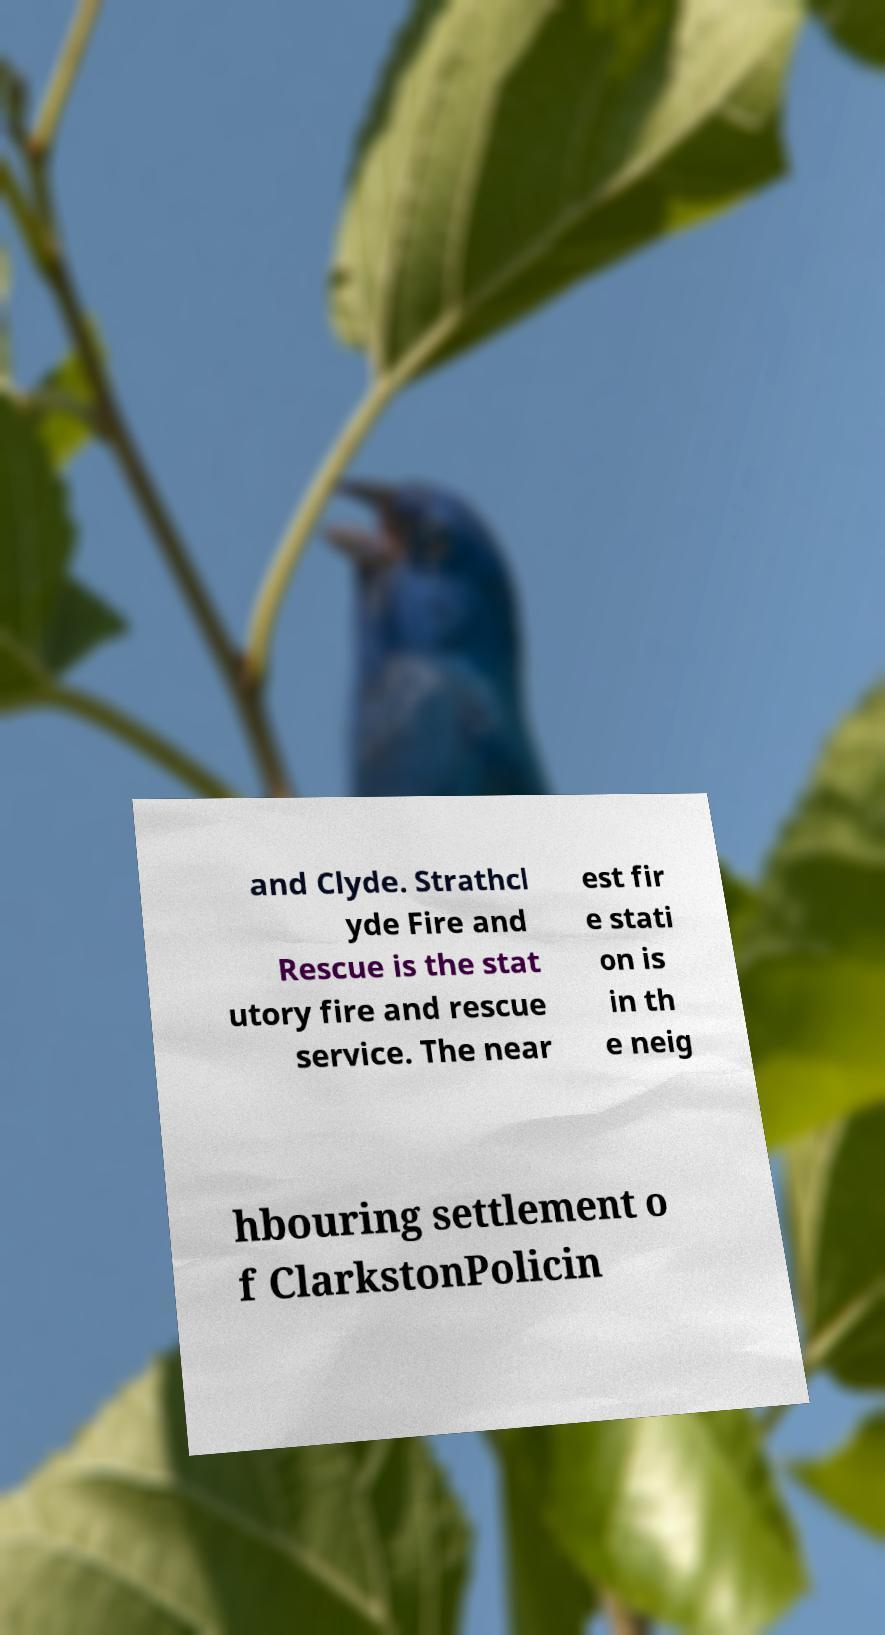For documentation purposes, I need the text within this image transcribed. Could you provide that? and Clyde. Strathcl yde Fire and Rescue is the stat utory fire and rescue service. The near est fir e stati on is in th e neig hbouring settlement o f ClarkstonPolicin 